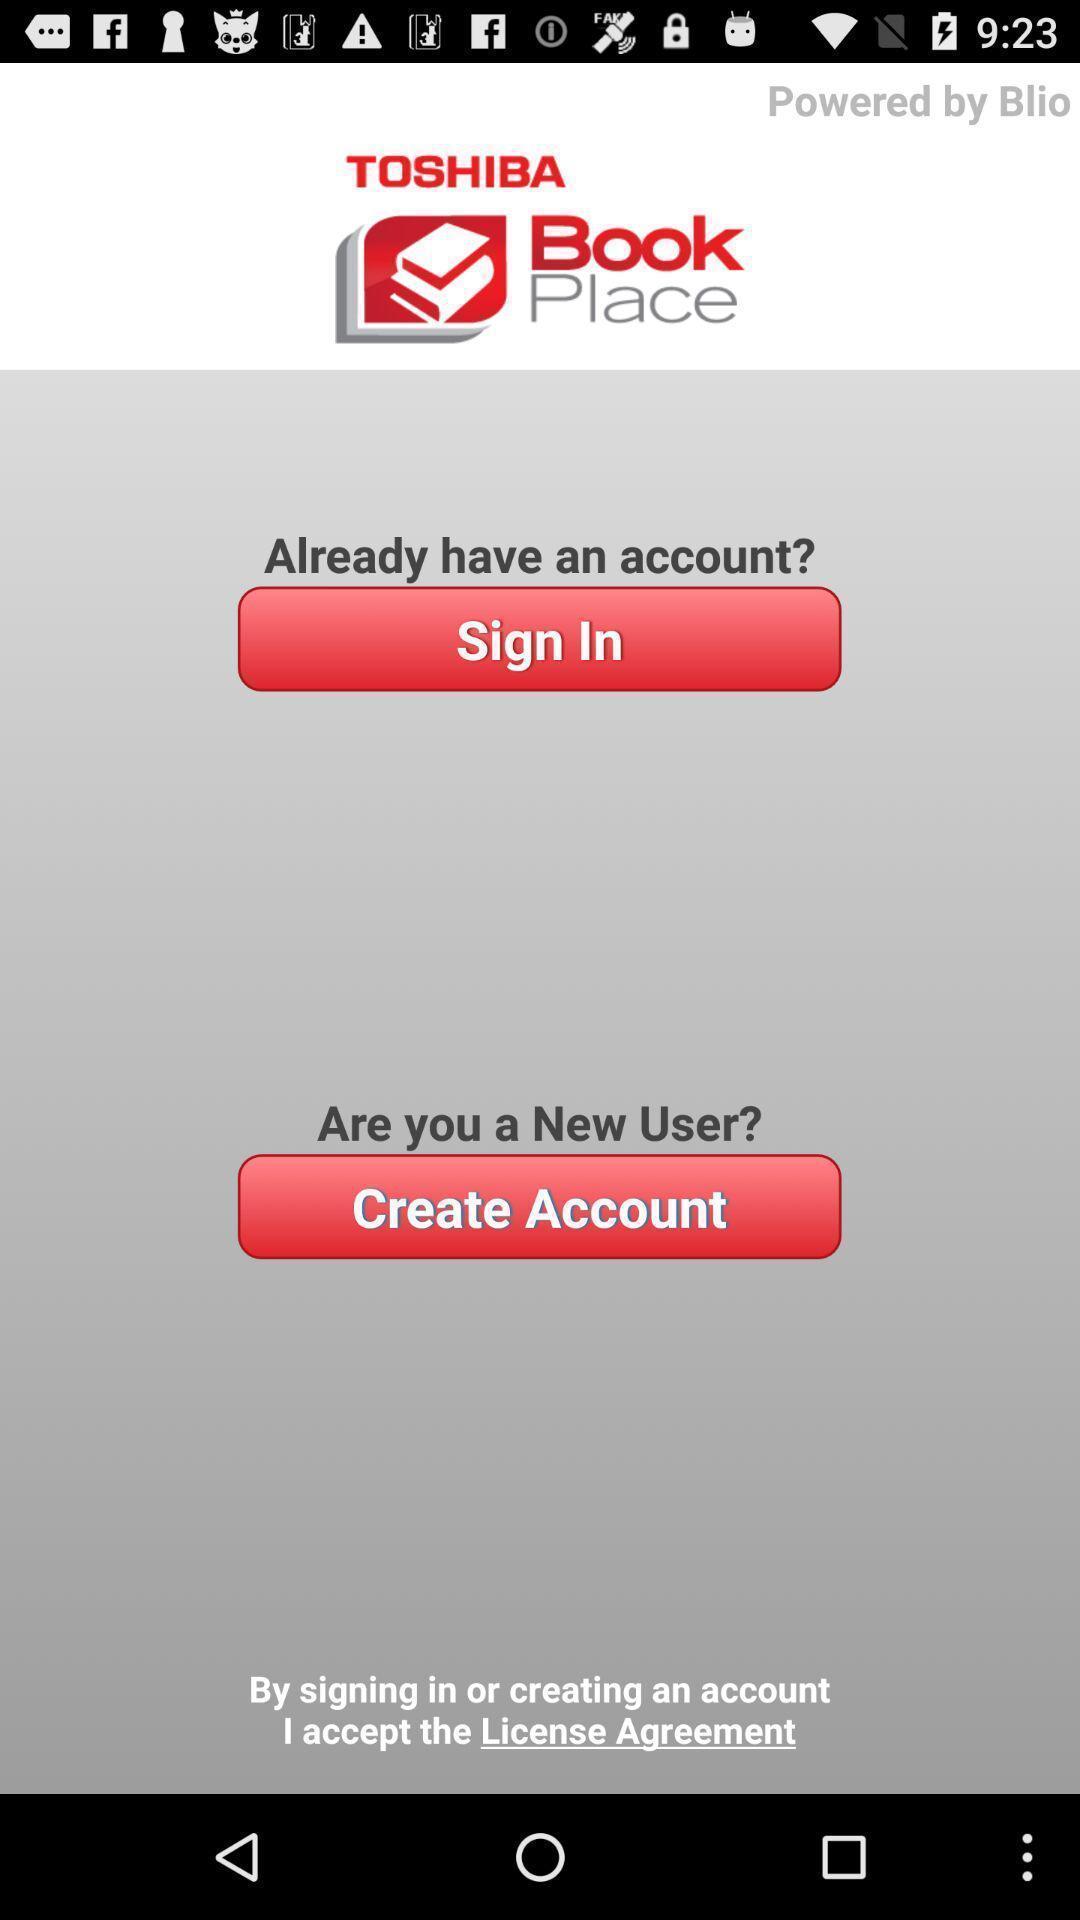What is the overall content of this screenshot? Sign in page. 